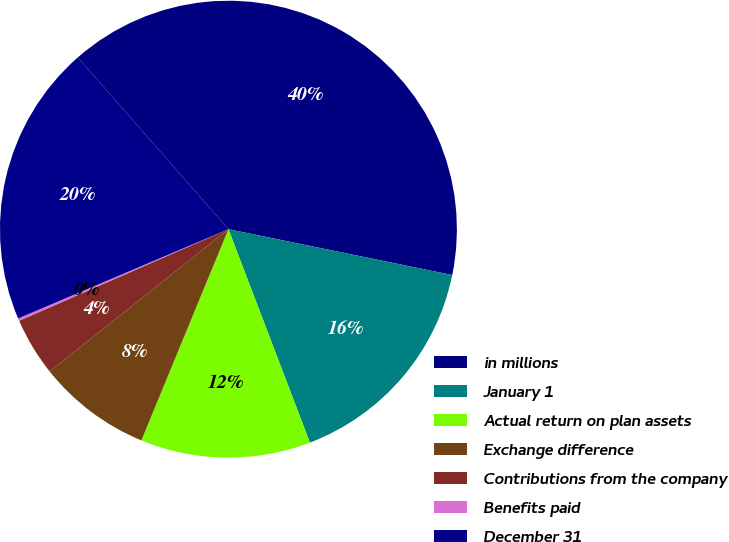<chart> <loc_0><loc_0><loc_500><loc_500><pie_chart><fcel>in millions<fcel>January 1<fcel>Actual return on plan assets<fcel>Exchange difference<fcel>Contributions from the company<fcel>Benefits paid<fcel>December 31<nl><fcel>39.68%<fcel>15.98%<fcel>12.03%<fcel>8.08%<fcel>4.13%<fcel>0.18%<fcel>19.93%<nl></chart> 